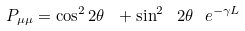Convert formula to latex. <formula><loc_0><loc_0><loc_500><loc_500>P _ { \mu \mu } = \cos ^ { 2 } 2 \theta \ + \sin ^ { 2 } \ 2 \theta \ e ^ { - \gamma L }</formula> 